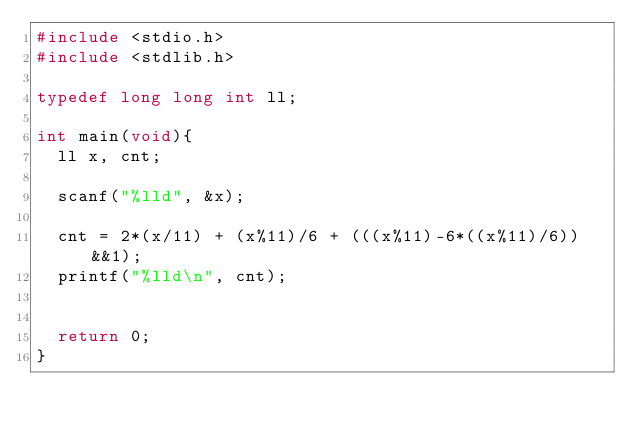<code> <loc_0><loc_0><loc_500><loc_500><_C_>#include <stdio.h>
#include <stdlib.h>

typedef long long int ll;

int main(void){
	ll x, cnt;

	scanf("%lld", &x);

	cnt = 2*(x/11) + (x%11)/6 + (((x%11)-6*((x%11)/6))&&1);
	printf("%lld\n", cnt);
	

	return 0;
}</code> 